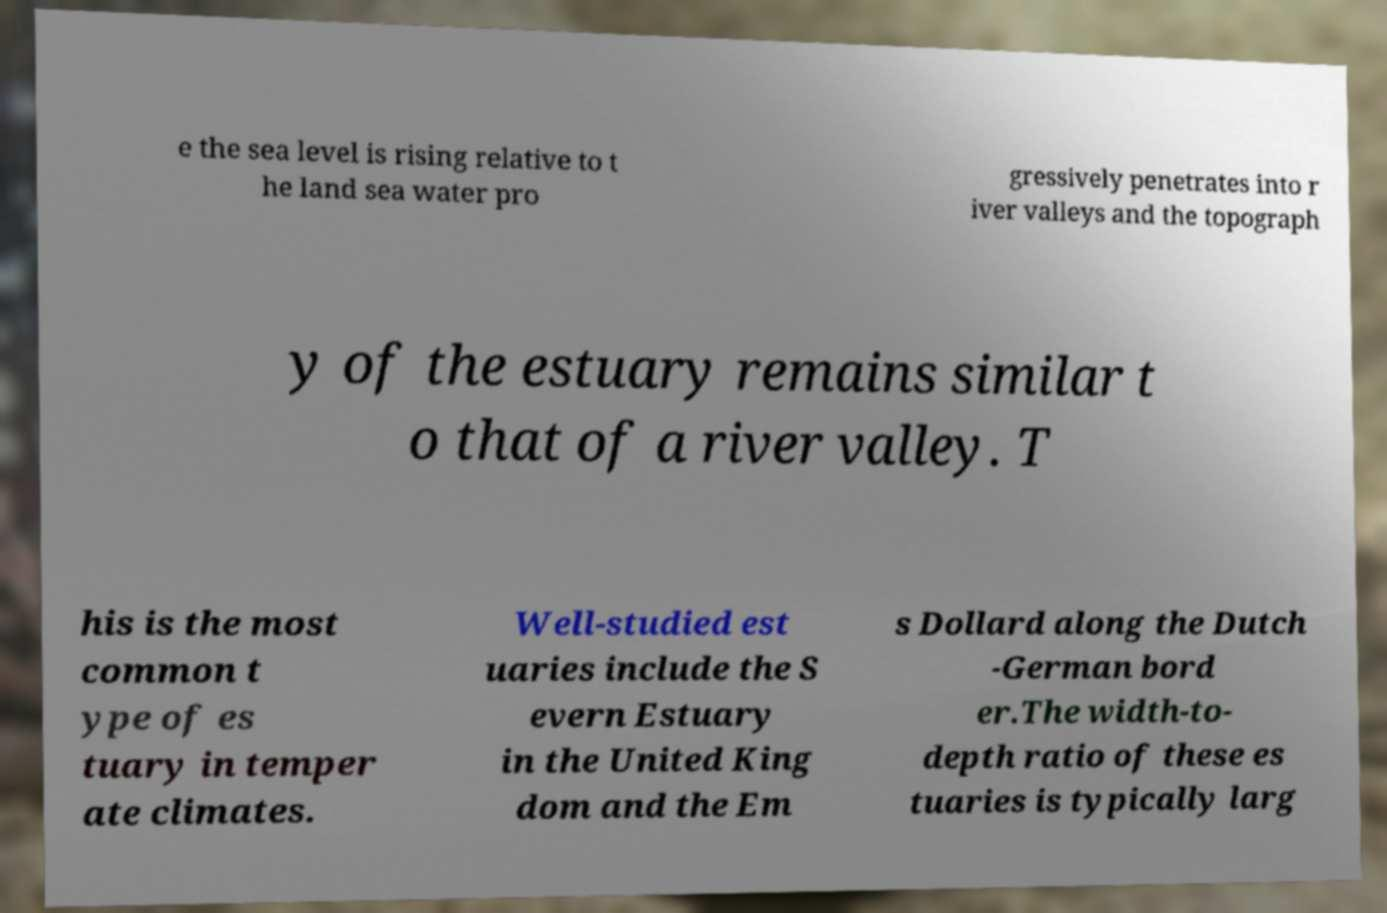I need the written content from this picture converted into text. Can you do that? e the sea level is rising relative to t he land sea water pro gressively penetrates into r iver valleys and the topograph y of the estuary remains similar t o that of a river valley. T his is the most common t ype of es tuary in temper ate climates. Well-studied est uaries include the S evern Estuary in the United King dom and the Em s Dollard along the Dutch -German bord er.The width-to- depth ratio of these es tuaries is typically larg 